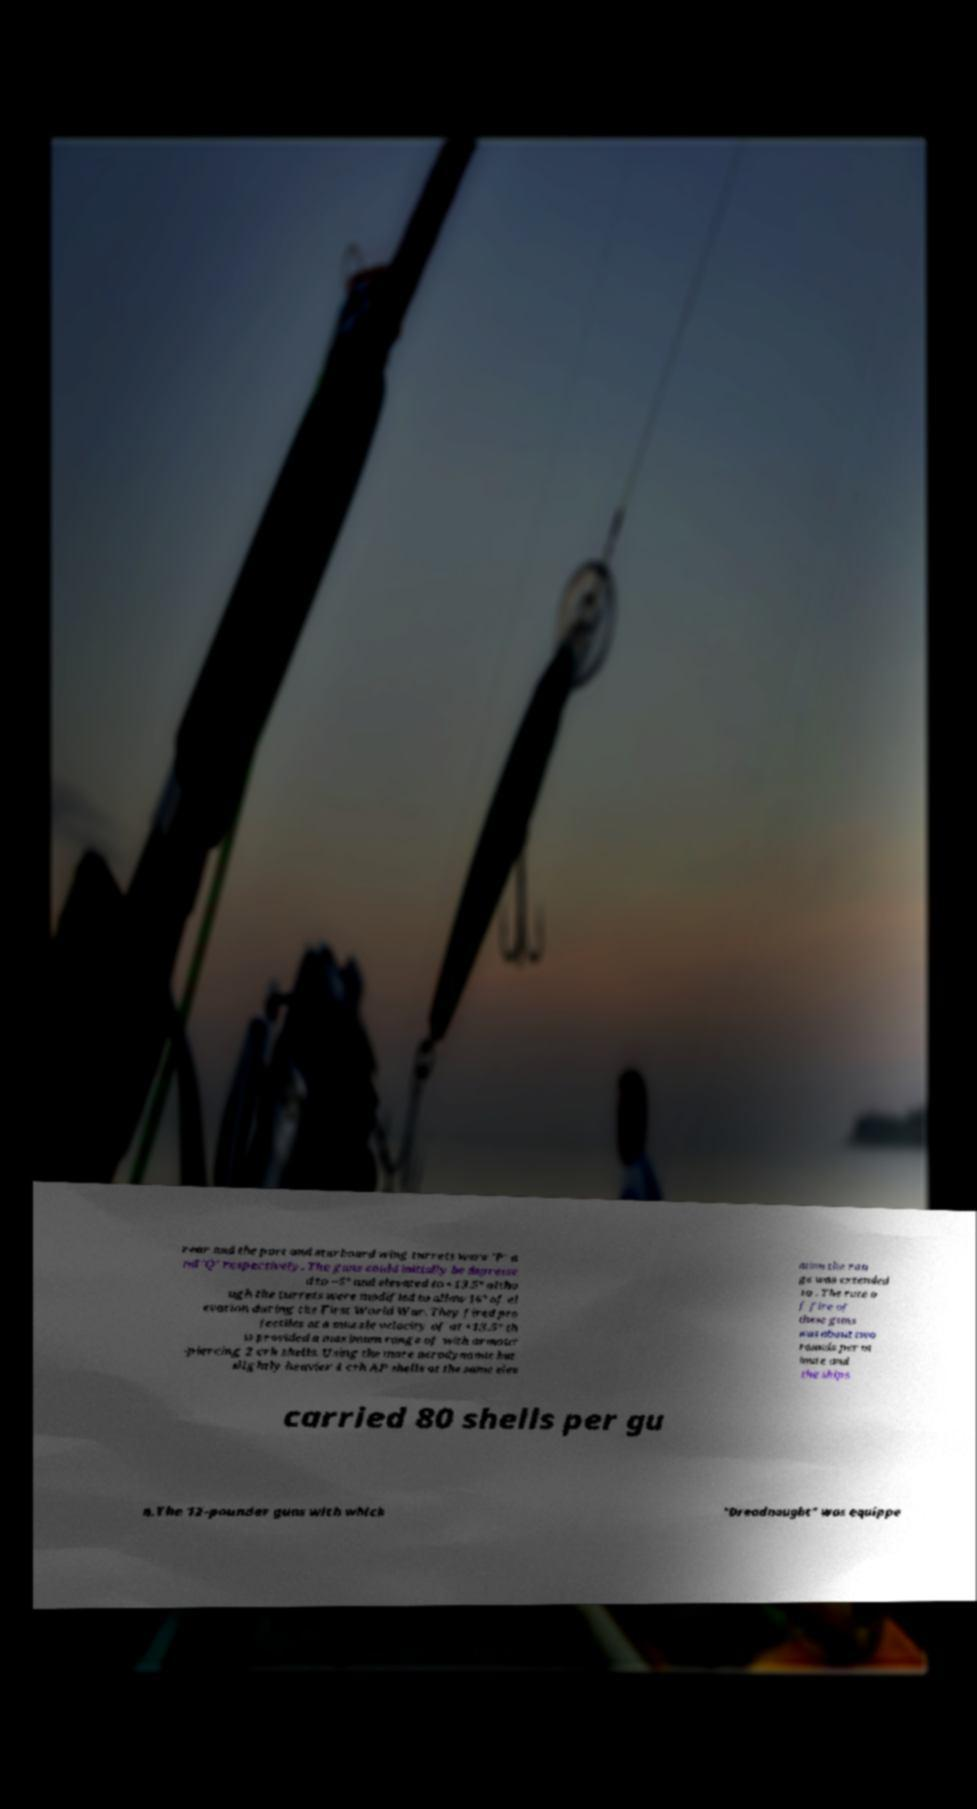Please read and relay the text visible in this image. What does it say? rear and the port and starboard wing turrets were 'P' a nd 'Q' respectively. The guns could initially be depresse d to −5° and elevated to +13.5° altho ugh the turrets were modified to allow 16° of el evation during the First World War. They fired pro jectiles at a muzzle velocity of at +13.5° th is provided a maximum range of with armour -piercing 2 crh shells. Using the more aerodynamic but slightly heavier 4 crh AP shells at the same elev ation the ran ge was extended to . The rate o f fire of these guns was about two rounds per m inute and the ships carried 80 shells per gu n.The 12-pounder guns with which "Dreadnought" was equippe 